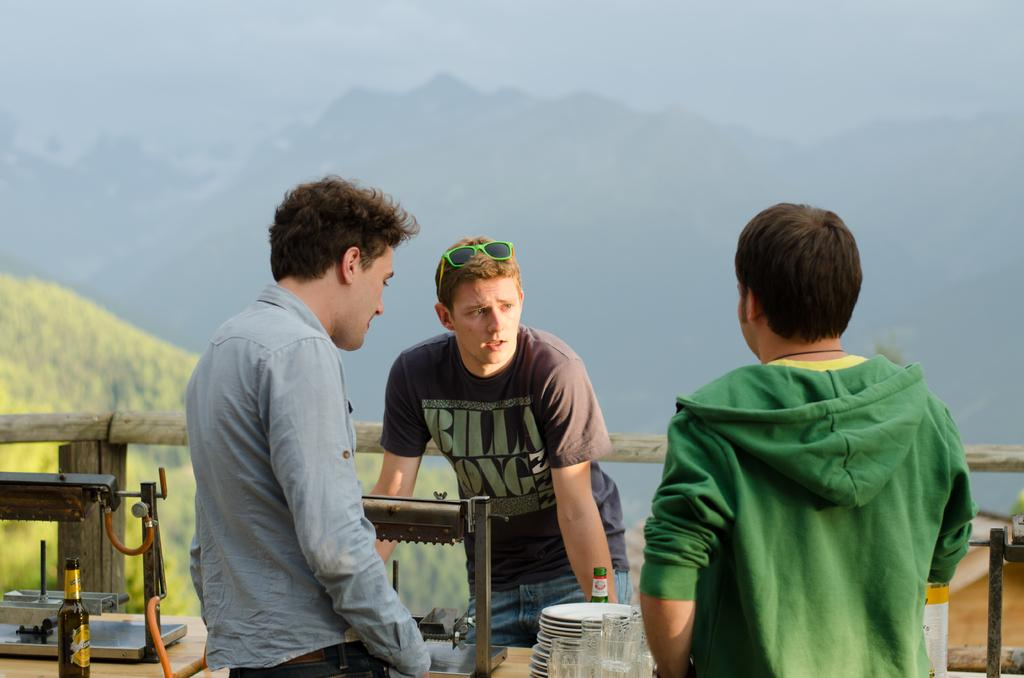How many people are in the image? There are three men in the image. What objects are present that might be used for eating or drinking? There are plates, glasses, and two bottles in the image. What additional item can be seen in the image? There is an equipment in the image. What type of marble is being used to play a game in the image? There is no marble or game present in the image; it features three men, plates, glasses, bottles, and an equipment. How many marks can be seen on the equipment in the image? There is no mention of marks on the equipment in the image, so it cannot be determined. 